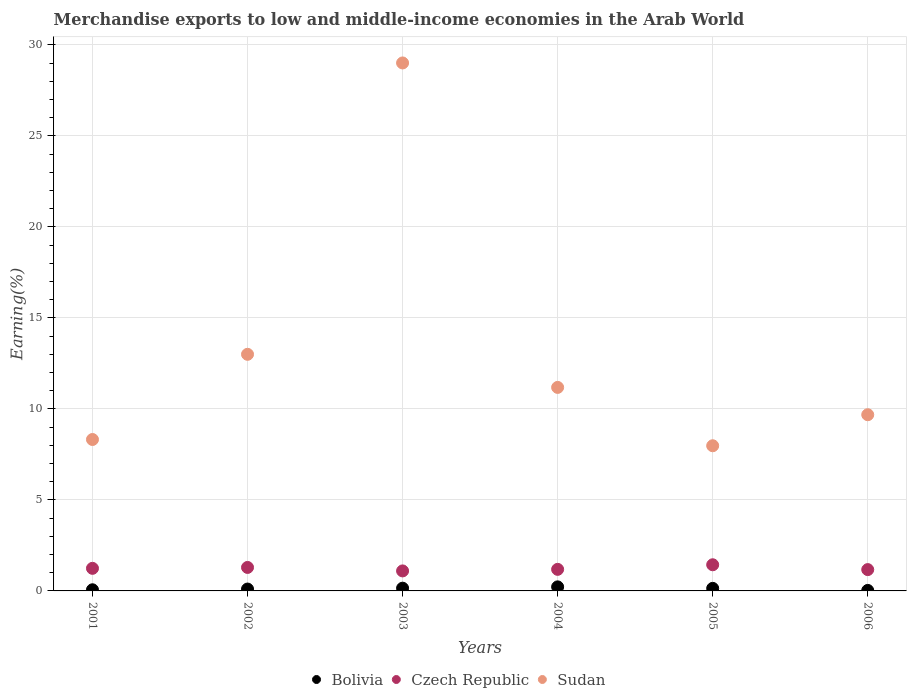How many different coloured dotlines are there?
Give a very brief answer. 3. What is the percentage of amount earned from merchandise exports in Sudan in 2002?
Provide a succinct answer. 13. Across all years, what is the maximum percentage of amount earned from merchandise exports in Czech Republic?
Your answer should be very brief. 1.44. Across all years, what is the minimum percentage of amount earned from merchandise exports in Sudan?
Your answer should be compact. 7.97. In which year was the percentage of amount earned from merchandise exports in Sudan maximum?
Your answer should be compact. 2003. In which year was the percentage of amount earned from merchandise exports in Sudan minimum?
Offer a terse response. 2005. What is the total percentage of amount earned from merchandise exports in Czech Republic in the graph?
Offer a very short reply. 7.42. What is the difference between the percentage of amount earned from merchandise exports in Czech Republic in 2004 and that in 2006?
Offer a terse response. 0.01. What is the difference between the percentage of amount earned from merchandise exports in Bolivia in 2006 and the percentage of amount earned from merchandise exports in Czech Republic in 2001?
Make the answer very short. -1.21. What is the average percentage of amount earned from merchandise exports in Sudan per year?
Your answer should be compact. 13.19. In the year 2006, what is the difference between the percentage of amount earned from merchandise exports in Bolivia and percentage of amount earned from merchandise exports in Sudan?
Offer a very short reply. -9.65. In how many years, is the percentage of amount earned from merchandise exports in Czech Republic greater than 9 %?
Provide a succinct answer. 0. What is the ratio of the percentage of amount earned from merchandise exports in Sudan in 2003 to that in 2005?
Keep it short and to the point. 3.64. What is the difference between the highest and the second highest percentage of amount earned from merchandise exports in Czech Republic?
Offer a very short reply. 0.15. What is the difference between the highest and the lowest percentage of amount earned from merchandise exports in Czech Republic?
Ensure brevity in your answer.  0.34. In how many years, is the percentage of amount earned from merchandise exports in Sudan greater than the average percentage of amount earned from merchandise exports in Sudan taken over all years?
Keep it short and to the point. 1. Is it the case that in every year, the sum of the percentage of amount earned from merchandise exports in Bolivia and percentage of amount earned from merchandise exports in Sudan  is greater than the percentage of amount earned from merchandise exports in Czech Republic?
Give a very brief answer. Yes. Does the percentage of amount earned from merchandise exports in Bolivia monotonically increase over the years?
Keep it short and to the point. No. Is the percentage of amount earned from merchandise exports in Bolivia strictly greater than the percentage of amount earned from merchandise exports in Sudan over the years?
Provide a short and direct response. No. Does the graph contain grids?
Your answer should be compact. Yes. Where does the legend appear in the graph?
Your response must be concise. Bottom center. What is the title of the graph?
Make the answer very short. Merchandise exports to low and middle-income economies in the Arab World. Does "Cayman Islands" appear as one of the legend labels in the graph?
Make the answer very short. No. What is the label or title of the X-axis?
Make the answer very short. Years. What is the label or title of the Y-axis?
Your answer should be compact. Earning(%). What is the Earning(%) in Bolivia in 2001?
Make the answer very short. 0.06. What is the Earning(%) of Czech Republic in 2001?
Ensure brevity in your answer.  1.24. What is the Earning(%) in Sudan in 2001?
Provide a short and direct response. 8.32. What is the Earning(%) in Bolivia in 2002?
Offer a terse response. 0.1. What is the Earning(%) in Czech Republic in 2002?
Make the answer very short. 1.29. What is the Earning(%) of Sudan in 2002?
Offer a terse response. 13. What is the Earning(%) of Bolivia in 2003?
Your response must be concise. 0.15. What is the Earning(%) of Czech Republic in 2003?
Keep it short and to the point. 1.1. What is the Earning(%) in Sudan in 2003?
Offer a terse response. 29. What is the Earning(%) of Bolivia in 2004?
Offer a terse response. 0.22. What is the Earning(%) in Czech Republic in 2004?
Ensure brevity in your answer.  1.18. What is the Earning(%) in Sudan in 2004?
Offer a terse response. 11.18. What is the Earning(%) of Bolivia in 2005?
Provide a succinct answer. 0.14. What is the Earning(%) in Czech Republic in 2005?
Your response must be concise. 1.44. What is the Earning(%) of Sudan in 2005?
Your response must be concise. 7.97. What is the Earning(%) in Bolivia in 2006?
Your answer should be very brief. 0.03. What is the Earning(%) of Czech Republic in 2006?
Your answer should be very brief. 1.17. What is the Earning(%) of Sudan in 2006?
Ensure brevity in your answer.  9.68. Across all years, what is the maximum Earning(%) in Bolivia?
Give a very brief answer. 0.22. Across all years, what is the maximum Earning(%) of Czech Republic?
Offer a terse response. 1.44. Across all years, what is the maximum Earning(%) in Sudan?
Provide a short and direct response. 29. Across all years, what is the minimum Earning(%) of Bolivia?
Offer a terse response. 0.03. Across all years, what is the minimum Earning(%) in Czech Republic?
Ensure brevity in your answer.  1.1. Across all years, what is the minimum Earning(%) of Sudan?
Give a very brief answer. 7.97. What is the total Earning(%) of Bolivia in the graph?
Keep it short and to the point. 0.71. What is the total Earning(%) of Czech Republic in the graph?
Offer a very short reply. 7.42. What is the total Earning(%) in Sudan in the graph?
Your response must be concise. 79.15. What is the difference between the Earning(%) of Bolivia in 2001 and that in 2002?
Give a very brief answer. -0.04. What is the difference between the Earning(%) of Czech Republic in 2001 and that in 2002?
Offer a terse response. -0.05. What is the difference between the Earning(%) of Sudan in 2001 and that in 2002?
Make the answer very short. -4.68. What is the difference between the Earning(%) in Bolivia in 2001 and that in 2003?
Give a very brief answer. -0.09. What is the difference between the Earning(%) in Czech Republic in 2001 and that in 2003?
Provide a succinct answer. 0.14. What is the difference between the Earning(%) of Sudan in 2001 and that in 2003?
Keep it short and to the point. -20.69. What is the difference between the Earning(%) in Bolivia in 2001 and that in 2004?
Ensure brevity in your answer.  -0.16. What is the difference between the Earning(%) in Czech Republic in 2001 and that in 2004?
Your answer should be very brief. 0.06. What is the difference between the Earning(%) in Sudan in 2001 and that in 2004?
Make the answer very short. -2.86. What is the difference between the Earning(%) of Bolivia in 2001 and that in 2005?
Make the answer very short. -0.08. What is the difference between the Earning(%) in Czech Republic in 2001 and that in 2005?
Your answer should be compact. -0.2. What is the difference between the Earning(%) of Sudan in 2001 and that in 2005?
Give a very brief answer. 0.34. What is the difference between the Earning(%) of Bolivia in 2001 and that in 2006?
Provide a short and direct response. 0.04. What is the difference between the Earning(%) in Czech Republic in 2001 and that in 2006?
Give a very brief answer. 0.07. What is the difference between the Earning(%) in Sudan in 2001 and that in 2006?
Ensure brevity in your answer.  -1.36. What is the difference between the Earning(%) of Bolivia in 2002 and that in 2003?
Give a very brief answer. -0.05. What is the difference between the Earning(%) of Czech Republic in 2002 and that in 2003?
Provide a succinct answer. 0.19. What is the difference between the Earning(%) in Sudan in 2002 and that in 2003?
Ensure brevity in your answer.  -16.01. What is the difference between the Earning(%) of Bolivia in 2002 and that in 2004?
Your answer should be very brief. -0.12. What is the difference between the Earning(%) of Czech Republic in 2002 and that in 2004?
Provide a succinct answer. 0.11. What is the difference between the Earning(%) in Sudan in 2002 and that in 2004?
Keep it short and to the point. 1.82. What is the difference between the Earning(%) of Bolivia in 2002 and that in 2005?
Offer a terse response. -0.04. What is the difference between the Earning(%) in Czech Republic in 2002 and that in 2005?
Offer a very short reply. -0.15. What is the difference between the Earning(%) in Sudan in 2002 and that in 2005?
Make the answer very short. 5.02. What is the difference between the Earning(%) of Bolivia in 2002 and that in 2006?
Offer a very short reply. 0.08. What is the difference between the Earning(%) of Czech Republic in 2002 and that in 2006?
Keep it short and to the point. 0.12. What is the difference between the Earning(%) in Sudan in 2002 and that in 2006?
Offer a very short reply. 3.32. What is the difference between the Earning(%) of Bolivia in 2003 and that in 2004?
Make the answer very short. -0.07. What is the difference between the Earning(%) of Czech Republic in 2003 and that in 2004?
Provide a short and direct response. -0.09. What is the difference between the Earning(%) of Sudan in 2003 and that in 2004?
Make the answer very short. 17.82. What is the difference between the Earning(%) of Bolivia in 2003 and that in 2005?
Provide a short and direct response. 0.01. What is the difference between the Earning(%) of Czech Republic in 2003 and that in 2005?
Provide a succinct answer. -0.34. What is the difference between the Earning(%) of Sudan in 2003 and that in 2005?
Your response must be concise. 21.03. What is the difference between the Earning(%) of Bolivia in 2003 and that in 2006?
Your answer should be compact. 0.12. What is the difference between the Earning(%) of Czech Republic in 2003 and that in 2006?
Your response must be concise. -0.07. What is the difference between the Earning(%) in Sudan in 2003 and that in 2006?
Give a very brief answer. 19.32. What is the difference between the Earning(%) of Bolivia in 2004 and that in 2005?
Provide a short and direct response. 0.08. What is the difference between the Earning(%) of Czech Republic in 2004 and that in 2005?
Offer a terse response. -0.25. What is the difference between the Earning(%) in Sudan in 2004 and that in 2005?
Provide a short and direct response. 3.21. What is the difference between the Earning(%) in Bolivia in 2004 and that in 2006?
Your response must be concise. 0.2. What is the difference between the Earning(%) in Czech Republic in 2004 and that in 2006?
Ensure brevity in your answer.  0.01. What is the difference between the Earning(%) of Sudan in 2004 and that in 2006?
Keep it short and to the point. 1.5. What is the difference between the Earning(%) in Bolivia in 2005 and that in 2006?
Ensure brevity in your answer.  0.11. What is the difference between the Earning(%) in Czech Republic in 2005 and that in 2006?
Your answer should be compact. 0.27. What is the difference between the Earning(%) of Sudan in 2005 and that in 2006?
Make the answer very short. -1.7. What is the difference between the Earning(%) in Bolivia in 2001 and the Earning(%) in Czech Republic in 2002?
Your answer should be very brief. -1.23. What is the difference between the Earning(%) of Bolivia in 2001 and the Earning(%) of Sudan in 2002?
Provide a succinct answer. -12.94. What is the difference between the Earning(%) of Czech Republic in 2001 and the Earning(%) of Sudan in 2002?
Your answer should be very brief. -11.76. What is the difference between the Earning(%) in Bolivia in 2001 and the Earning(%) in Czech Republic in 2003?
Provide a short and direct response. -1.04. What is the difference between the Earning(%) of Bolivia in 2001 and the Earning(%) of Sudan in 2003?
Make the answer very short. -28.94. What is the difference between the Earning(%) in Czech Republic in 2001 and the Earning(%) in Sudan in 2003?
Provide a succinct answer. -27.76. What is the difference between the Earning(%) in Bolivia in 2001 and the Earning(%) in Czech Republic in 2004?
Give a very brief answer. -1.12. What is the difference between the Earning(%) in Bolivia in 2001 and the Earning(%) in Sudan in 2004?
Offer a very short reply. -11.12. What is the difference between the Earning(%) of Czech Republic in 2001 and the Earning(%) of Sudan in 2004?
Provide a succinct answer. -9.94. What is the difference between the Earning(%) of Bolivia in 2001 and the Earning(%) of Czech Republic in 2005?
Your answer should be very brief. -1.37. What is the difference between the Earning(%) in Bolivia in 2001 and the Earning(%) in Sudan in 2005?
Your answer should be compact. -7.91. What is the difference between the Earning(%) in Czech Republic in 2001 and the Earning(%) in Sudan in 2005?
Provide a short and direct response. -6.73. What is the difference between the Earning(%) of Bolivia in 2001 and the Earning(%) of Czech Republic in 2006?
Offer a terse response. -1.11. What is the difference between the Earning(%) of Bolivia in 2001 and the Earning(%) of Sudan in 2006?
Provide a succinct answer. -9.62. What is the difference between the Earning(%) in Czech Republic in 2001 and the Earning(%) in Sudan in 2006?
Provide a short and direct response. -8.44. What is the difference between the Earning(%) of Bolivia in 2002 and the Earning(%) of Czech Republic in 2003?
Offer a terse response. -1. What is the difference between the Earning(%) of Bolivia in 2002 and the Earning(%) of Sudan in 2003?
Ensure brevity in your answer.  -28.9. What is the difference between the Earning(%) of Czech Republic in 2002 and the Earning(%) of Sudan in 2003?
Make the answer very short. -27.71. What is the difference between the Earning(%) in Bolivia in 2002 and the Earning(%) in Czech Republic in 2004?
Your response must be concise. -1.08. What is the difference between the Earning(%) of Bolivia in 2002 and the Earning(%) of Sudan in 2004?
Your answer should be very brief. -11.08. What is the difference between the Earning(%) in Czech Republic in 2002 and the Earning(%) in Sudan in 2004?
Ensure brevity in your answer.  -9.89. What is the difference between the Earning(%) in Bolivia in 2002 and the Earning(%) in Czech Republic in 2005?
Give a very brief answer. -1.33. What is the difference between the Earning(%) in Bolivia in 2002 and the Earning(%) in Sudan in 2005?
Keep it short and to the point. -7.87. What is the difference between the Earning(%) of Czech Republic in 2002 and the Earning(%) of Sudan in 2005?
Your response must be concise. -6.68. What is the difference between the Earning(%) of Bolivia in 2002 and the Earning(%) of Czech Republic in 2006?
Provide a short and direct response. -1.07. What is the difference between the Earning(%) of Bolivia in 2002 and the Earning(%) of Sudan in 2006?
Provide a succinct answer. -9.58. What is the difference between the Earning(%) of Czech Republic in 2002 and the Earning(%) of Sudan in 2006?
Provide a short and direct response. -8.39. What is the difference between the Earning(%) in Bolivia in 2003 and the Earning(%) in Czech Republic in 2004?
Make the answer very short. -1.03. What is the difference between the Earning(%) of Bolivia in 2003 and the Earning(%) of Sudan in 2004?
Ensure brevity in your answer.  -11.03. What is the difference between the Earning(%) of Czech Republic in 2003 and the Earning(%) of Sudan in 2004?
Give a very brief answer. -10.08. What is the difference between the Earning(%) in Bolivia in 2003 and the Earning(%) in Czech Republic in 2005?
Offer a terse response. -1.29. What is the difference between the Earning(%) in Bolivia in 2003 and the Earning(%) in Sudan in 2005?
Ensure brevity in your answer.  -7.82. What is the difference between the Earning(%) of Czech Republic in 2003 and the Earning(%) of Sudan in 2005?
Your response must be concise. -6.88. What is the difference between the Earning(%) of Bolivia in 2003 and the Earning(%) of Czech Republic in 2006?
Provide a short and direct response. -1.02. What is the difference between the Earning(%) in Bolivia in 2003 and the Earning(%) in Sudan in 2006?
Ensure brevity in your answer.  -9.53. What is the difference between the Earning(%) in Czech Republic in 2003 and the Earning(%) in Sudan in 2006?
Make the answer very short. -8.58. What is the difference between the Earning(%) of Bolivia in 2004 and the Earning(%) of Czech Republic in 2005?
Your answer should be very brief. -1.21. What is the difference between the Earning(%) of Bolivia in 2004 and the Earning(%) of Sudan in 2005?
Provide a succinct answer. -7.75. What is the difference between the Earning(%) in Czech Republic in 2004 and the Earning(%) in Sudan in 2005?
Provide a short and direct response. -6.79. What is the difference between the Earning(%) of Bolivia in 2004 and the Earning(%) of Czech Republic in 2006?
Make the answer very short. -0.95. What is the difference between the Earning(%) of Bolivia in 2004 and the Earning(%) of Sudan in 2006?
Provide a succinct answer. -9.46. What is the difference between the Earning(%) of Czech Republic in 2004 and the Earning(%) of Sudan in 2006?
Give a very brief answer. -8.49. What is the difference between the Earning(%) of Bolivia in 2005 and the Earning(%) of Czech Republic in 2006?
Your answer should be compact. -1.03. What is the difference between the Earning(%) in Bolivia in 2005 and the Earning(%) in Sudan in 2006?
Your answer should be compact. -9.54. What is the difference between the Earning(%) of Czech Republic in 2005 and the Earning(%) of Sudan in 2006?
Ensure brevity in your answer.  -8.24. What is the average Earning(%) in Bolivia per year?
Give a very brief answer. 0.12. What is the average Earning(%) in Czech Republic per year?
Ensure brevity in your answer.  1.24. What is the average Earning(%) in Sudan per year?
Provide a succinct answer. 13.19. In the year 2001, what is the difference between the Earning(%) in Bolivia and Earning(%) in Czech Republic?
Ensure brevity in your answer.  -1.18. In the year 2001, what is the difference between the Earning(%) of Bolivia and Earning(%) of Sudan?
Provide a succinct answer. -8.26. In the year 2001, what is the difference between the Earning(%) of Czech Republic and Earning(%) of Sudan?
Offer a very short reply. -7.08. In the year 2002, what is the difference between the Earning(%) in Bolivia and Earning(%) in Czech Republic?
Ensure brevity in your answer.  -1.19. In the year 2002, what is the difference between the Earning(%) in Bolivia and Earning(%) in Sudan?
Keep it short and to the point. -12.9. In the year 2002, what is the difference between the Earning(%) in Czech Republic and Earning(%) in Sudan?
Your response must be concise. -11.71. In the year 2003, what is the difference between the Earning(%) of Bolivia and Earning(%) of Czech Republic?
Offer a terse response. -0.95. In the year 2003, what is the difference between the Earning(%) of Bolivia and Earning(%) of Sudan?
Make the answer very short. -28.85. In the year 2003, what is the difference between the Earning(%) of Czech Republic and Earning(%) of Sudan?
Make the answer very short. -27.9. In the year 2004, what is the difference between the Earning(%) in Bolivia and Earning(%) in Czech Republic?
Offer a very short reply. -0.96. In the year 2004, what is the difference between the Earning(%) of Bolivia and Earning(%) of Sudan?
Provide a succinct answer. -10.96. In the year 2004, what is the difference between the Earning(%) of Czech Republic and Earning(%) of Sudan?
Your answer should be very brief. -10. In the year 2005, what is the difference between the Earning(%) in Bolivia and Earning(%) in Czech Republic?
Provide a short and direct response. -1.3. In the year 2005, what is the difference between the Earning(%) of Bolivia and Earning(%) of Sudan?
Offer a very short reply. -7.83. In the year 2005, what is the difference between the Earning(%) of Czech Republic and Earning(%) of Sudan?
Offer a terse response. -6.54. In the year 2006, what is the difference between the Earning(%) of Bolivia and Earning(%) of Czech Republic?
Give a very brief answer. -1.14. In the year 2006, what is the difference between the Earning(%) of Bolivia and Earning(%) of Sudan?
Your response must be concise. -9.65. In the year 2006, what is the difference between the Earning(%) in Czech Republic and Earning(%) in Sudan?
Give a very brief answer. -8.51. What is the ratio of the Earning(%) in Bolivia in 2001 to that in 2002?
Ensure brevity in your answer.  0.61. What is the ratio of the Earning(%) of Czech Republic in 2001 to that in 2002?
Your response must be concise. 0.96. What is the ratio of the Earning(%) in Sudan in 2001 to that in 2002?
Your response must be concise. 0.64. What is the ratio of the Earning(%) in Bolivia in 2001 to that in 2003?
Offer a very short reply. 0.42. What is the ratio of the Earning(%) in Czech Republic in 2001 to that in 2003?
Offer a very short reply. 1.13. What is the ratio of the Earning(%) of Sudan in 2001 to that in 2003?
Keep it short and to the point. 0.29. What is the ratio of the Earning(%) of Bolivia in 2001 to that in 2004?
Keep it short and to the point. 0.28. What is the ratio of the Earning(%) in Czech Republic in 2001 to that in 2004?
Give a very brief answer. 1.05. What is the ratio of the Earning(%) in Sudan in 2001 to that in 2004?
Your answer should be very brief. 0.74. What is the ratio of the Earning(%) in Bolivia in 2001 to that in 2005?
Offer a terse response. 0.45. What is the ratio of the Earning(%) in Czech Republic in 2001 to that in 2005?
Give a very brief answer. 0.86. What is the ratio of the Earning(%) of Sudan in 2001 to that in 2005?
Provide a short and direct response. 1.04. What is the ratio of the Earning(%) in Bolivia in 2001 to that in 2006?
Your answer should be very brief. 2.28. What is the ratio of the Earning(%) in Czech Republic in 2001 to that in 2006?
Offer a very short reply. 1.06. What is the ratio of the Earning(%) of Sudan in 2001 to that in 2006?
Provide a succinct answer. 0.86. What is the ratio of the Earning(%) in Bolivia in 2002 to that in 2003?
Keep it short and to the point. 0.68. What is the ratio of the Earning(%) in Czech Republic in 2002 to that in 2003?
Give a very brief answer. 1.17. What is the ratio of the Earning(%) in Sudan in 2002 to that in 2003?
Your answer should be very brief. 0.45. What is the ratio of the Earning(%) in Bolivia in 2002 to that in 2004?
Give a very brief answer. 0.46. What is the ratio of the Earning(%) in Czech Republic in 2002 to that in 2004?
Keep it short and to the point. 1.09. What is the ratio of the Earning(%) in Sudan in 2002 to that in 2004?
Your answer should be compact. 1.16. What is the ratio of the Earning(%) in Bolivia in 2002 to that in 2005?
Provide a short and direct response. 0.73. What is the ratio of the Earning(%) in Czech Republic in 2002 to that in 2005?
Make the answer very short. 0.9. What is the ratio of the Earning(%) in Sudan in 2002 to that in 2005?
Your answer should be compact. 1.63. What is the ratio of the Earning(%) in Bolivia in 2002 to that in 2006?
Make the answer very short. 3.73. What is the ratio of the Earning(%) of Czech Republic in 2002 to that in 2006?
Your answer should be compact. 1.1. What is the ratio of the Earning(%) of Sudan in 2002 to that in 2006?
Make the answer very short. 1.34. What is the ratio of the Earning(%) in Bolivia in 2003 to that in 2004?
Keep it short and to the point. 0.68. What is the ratio of the Earning(%) of Czech Republic in 2003 to that in 2004?
Offer a terse response. 0.93. What is the ratio of the Earning(%) of Sudan in 2003 to that in 2004?
Offer a terse response. 2.59. What is the ratio of the Earning(%) in Bolivia in 2003 to that in 2005?
Your answer should be very brief. 1.07. What is the ratio of the Earning(%) of Czech Republic in 2003 to that in 2005?
Offer a terse response. 0.76. What is the ratio of the Earning(%) in Sudan in 2003 to that in 2005?
Your response must be concise. 3.64. What is the ratio of the Earning(%) in Bolivia in 2003 to that in 2006?
Your response must be concise. 5.47. What is the ratio of the Earning(%) in Czech Republic in 2003 to that in 2006?
Offer a terse response. 0.94. What is the ratio of the Earning(%) of Sudan in 2003 to that in 2006?
Give a very brief answer. 3. What is the ratio of the Earning(%) in Bolivia in 2004 to that in 2005?
Offer a very short reply. 1.58. What is the ratio of the Earning(%) of Czech Republic in 2004 to that in 2005?
Offer a very short reply. 0.82. What is the ratio of the Earning(%) of Sudan in 2004 to that in 2005?
Keep it short and to the point. 1.4. What is the ratio of the Earning(%) of Bolivia in 2004 to that in 2006?
Provide a succinct answer. 8.08. What is the ratio of the Earning(%) in Czech Republic in 2004 to that in 2006?
Offer a terse response. 1.01. What is the ratio of the Earning(%) in Sudan in 2004 to that in 2006?
Keep it short and to the point. 1.16. What is the ratio of the Earning(%) of Bolivia in 2005 to that in 2006?
Give a very brief answer. 5.1. What is the ratio of the Earning(%) in Czech Republic in 2005 to that in 2006?
Your answer should be compact. 1.23. What is the ratio of the Earning(%) in Sudan in 2005 to that in 2006?
Your response must be concise. 0.82. What is the difference between the highest and the second highest Earning(%) in Bolivia?
Offer a terse response. 0.07. What is the difference between the highest and the second highest Earning(%) of Czech Republic?
Keep it short and to the point. 0.15. What is the difference between the highest and the second highest Earning(%) of Sudan?
Your answer should be compact. 16.01. What is the difference between the highest and the lowest Earning(%) of Bolivia?
Provide a succinct answer. 0.2. What is the difference between the highest and the lowest Earning(%) in Czech Republic?
Ensure brevity in your answer.  0.34. What is the difference between the highest and the lowest Earning(%) of Sudan?
Your answer should be compact. 21.03. 